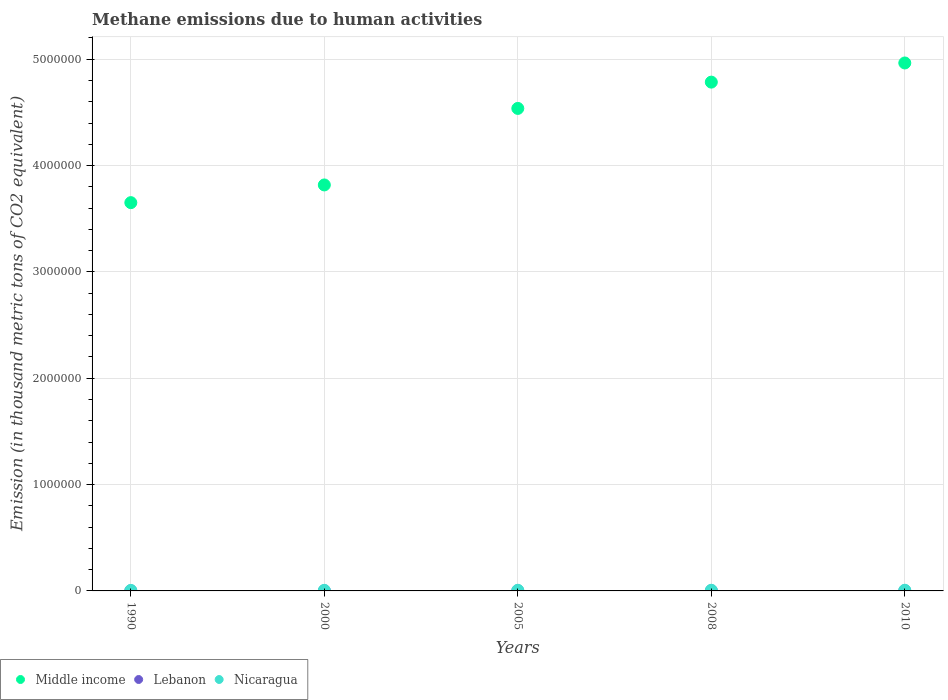How many different coloured dotlines are there?
Provide a short and direct response. 3. Is the number of dotlines equal to the number of legend labels?
Provide a short and direct response. Yes. What is the amount of methane emitted in Nicaragua in 2010?
Your answer should be very brief. 6361.4. Across all years, what is the maximum amount of methane emitted in Middle income?
Provide a succinct answer. 4.96e+06. Across all years, what is the minimum amount of methane emitted in Lebanon?
Make the answer very short. 699. In which year was the amount of methane emitted in Middle income minimum?
Your answer should be compact. 1990. What is the total amount of methane emitted in Middle income in the graph?
Give a very brief answer. 2.18e+07. What is the difference between the amount of methane emitted in Lebanon in 1990 and that in 2000?
Make the answer very short. -207.6. What is the difference between the amount of methane emitted in Middle income in 1990 and the amount of methane emitted in Nicaragua in 2000?
Your answer should be very brief. 3.65e+06. What is the average amount of methane emitted in Lebanon per year?
Your answer should be compact. 969.9. In the year 2005, what is the difference between the amount of methane emitted in Nicaragua and amount of methane emitted in Lebanon?
Ensure brevity in your answer.  5020.2. What is the ratio of the amount of methane emitted in Nicaragua in 2000 to that in 2005?
Offer a very short reply. 0.92. Is the amount of methane emitted in Nicaragua in 2000 less than that in 2005?
Make the answer very short. Yes. What is the difference between the highest and the second highest amount of methane emitted in Middle income?
Your answer should be very brief. 1.80e+05. What is the difference between the highest and the lowest amount of methane emitted in Lebanon?
Give a very brief answer. 428.4. In how many years, is the amount of methane emitted in Middle income greater than the average amount of methane emitted in Middle income taken over all years?
Provide a succinct answer. 3. How many years are there in the graph?
Keep it short and to the point. 5. What is the difference between two consecutive major ticks on the Y-axis?
Ensure brevity in your answer.  1.00e+06. Does the graph contain any zero values?
Your answer should be compact. No. How many legend labels are there?
Keep it short and to the point. 3. How are the legend labels stacked?
Offer a terse response. Horizontal. What is the title of the graph?
Your response must be concise. Methane emissions due to human activities. Does "Mali" appear as one of the legend labels in the graph?
Give a very brief answer. No. What is the label or title of the Y-axis?
Provide a succinct answer. Emission (in thousand metric tons of CO2 equivalent). What is the Emission (in thousand metric tons of CO2 equivalent) of Middle income in 1990?
Give a very brief answer. 3.65e+06. What is the Emission (in thousand metric tons of CO2 equivalent) in Lebanon in 1990?
Provide a succinct answer. 699. What is the Emission (in thousand metric tons of CO2 equivalent) in Nicaragua in 1990?
Ensure brevity in your answer.  4811.3. What is the Emission (in thousand metric tons of CO2 equivalent) in Middle income in 2000?
Your response must be concise. 3.82e+06. What is the Emission (in thousand metric tons of CO2 equivalent) of Lebanon in 2000?
Make the answer very short. 906.6. What is the Emission (in thousand metric tons of CO2 equivalent) of Nicaragua in 2000?
Offer a terse response. 5565.7. What is the Emission (in thousand metric tons of CO2 equivalent) of Middle income in 2005?
Offer a very short reply. 4.54e+06. What is the Emission (in thousand metric tons of CO2 equivalent) in Lebanon in 2005?
Give a very brief answer. 1024.8. What is the Emission (in thousand metric tons of CO2 equivalent) of Nicaragua in 2005?
Offer a very short reply. 6045. What is the Emission (in thousand metric tons of CO2 equivalent) in Middle income in 2008?
Provide a succinct answer. 4.78e+06. What is the Emission (in thousand metric tons of CO2 equivalent) of Lebanon in 2008?
Make the answer very short. 1091.7. What is the Emission (in thousand metric tons of CO2 equivalent) of Nicaragua in 2008?
Ensure brevity in your answer.  6199.5. What is the Emission (in thousand metric tons of CO2 equivalent) of Middle income in 2010?
Keep it short and to the point. 4.96e+06. What is the Emission (in thousand metric tons of CO2 equivalent) in Lebanon in 2010?
Ensure brevity in your answer.  1127.4. What is the Emission (in thousand metric tons of CO2 equivalent) in Nicaragua in 2010?
Provide a short and direct response. 6361.4. Across all years, what is the maximum Emission (in thousand metric tons of CO2 equivalent) of Middle income?
Offer a terse response. 4.96e+06. Across all years, what is the maximum Emission (in thousand metric tons of CO2 equivalent) of Lebanon?
Your answer should be compact. 1127.4. Across all years, what is the maximum Emission (in thousand metric tons of CO2 equivalent) in Nicaragua?
Provide a short and direct response. 6361.4. Across all years, what is the minimum Emission (in thousand metric tons of CO2 equivalent) in Middle income?
Give a very brief answer. 3.65e+06. Across all years, what is the minimum Emission (in thousand metric tons of CO2 equivalent) in Lebanon?
Ensure brevity in your answer.  699. Across all years, what is the minimum Emission (in thousand metric tons of CO2 equivalent) in Nicaragua?
Your answer should be very brief. 4811.3. What is the total Emission (in thousand metric tons of CO2 equivalent) in Middle income in the graph?
Your response must be concise. 2.18e+07. What is the total Emission (in thousand metric tons of CO2 equivalent) in Lebanon in the graph?
Provide a succinct answer. 4849.5. What is the total Emission (in thousand metric tons of CO2 equivalent) of Nicaragua in the graph?
Make the answer very short. 2.90e+04. What is the difference between the Emission (in thousand metric tons of CO2 equivalent) in Middle income in 1990 and that in 2000?
Make the answer very short. -1.67e+05. What is the difference between the Emission (in thousand metric tons of CO2 equivalent) of Lebanon in 1990 and that in 2000?
Keep it short and to the point. -207.6. What is the difference between the Emission (in thousand metric tons of CO2 equivalent) of Nicaragua in 1990 and that in 2000?
Give a very brief answer. -754.4. What is the difference between the Emission (in thousand metric tons of CO2 equivalent) in Middle income in 1990 and that in 2005?
Keep it short and to the point. -8.86e+05. What is the difference between the Emission (in thousand metric tons of CO2 equivalent) in Lebanon in 1990 and that in 2005?
Offer a very short reply. -325.8. What is the difference between the Emission (in thousand metric tons of CO2 equivalent) in Nicaragua in 1990 and that in 2005?
Make the answer very short. -1233.7. What is the difference between the Emission (in thousand metric tons of CO2 equivalent) of Middle income in 1990 and that in 2008?
Make the answer very short. -1.13e+06. What is the difference between the Emission (in thousand metric tons of CO2 equivalent) in Lebanon in 1990 and that in 2008?
Offer a terse response. -392.7. What is the difference between the Emission (in thousand metric tons of CO2 equivalent) of Nicaragua in 1990 and that in 2008?
Provide a short and direct response. -1388.2. What is the difference between the Emission (in thousand metric tons of CO2 equivalent) in Middle income in 1990 and that in 2010?
Your response must be concise. -1.31e+06. What is the difference between the Emission (in thousand metric tons of CO2 equivalent) in Lebanon in 1990 and that in 2010?
Provide a short and direct response. -428.4. What is the difference between the Emission (in thousand metric tons of CO2 equivalent) of Nicaragua in 1990 and that in 2010?
Provide a short and direct response. -1550.1. What is the difference between the Emission (in thousand metric tons of CO2 equivalent) of Middle income in 2000 and that in 2005?
Your answer should be compact. -7.20e+05. What is the difference between the Emission (in thousand metric tons of CO2 equivalent) in Lebanon in 2000 and that in 2005?
Your answer should be compact. -118.2. What is the difference between the Emission (in thousand metric tons of CO2 equivalent) in Nicaragua in 2000 and that in 2005?
Offer a terse response. -479.3. What is the difference between the Emission (in thousand metric tons of CO2 equivalent) of Middle income in 2000 and that in 2008?
Provide a succinct answer. -9.67e+05. What is the difference between the Emission (in thousand metric tons of CO2 equivalent) of Lebanon in 2000 and that in 2008?
Provide a succinct answer. -185.1. What is the difference between the Emission (in thousand metric tons of CO2 equivalent) in Nicaragua in 2000 and that in 2008?
Offer a very short reply. -633.8. What is the difference between the Emission (in thousand metric tons of CO2 equivalent) of Middle income in 2000 and that in 2010?
Your answer should be very brief. -1.15e+06. What is the difference between the Emission (in thousand metric tons of CO2 equivalent) of Lebanon in 2000 and that in 2010?
Your answer should be very brief. -220.8. What is the difference between the Emission (in thousand metric tons of CO2 equivalent) of Nicaragua in 2000 and that in 2010?
Offer a terse response. -795.7. What is the difference between the Emission (in thousand metric tons of CO2 equivalent) in Middle income in 2005 and that in 2008?
Your answer should be very brief. -2.47e+05. What is the difference between the Emission (in thousand metric tons of CO2 equivalent) of Lebanon in 2005 and that in 2008?
Provide a short and direct response. -66.9. What is the difference between the Emission (in thousand metric tons of CO2 equivalent) in Nicaragua in 2005 and that in 2008?
Ensure brevity in your answer.  -154.5. What is the difference between the Emission (in thousand metric tons of CO2 equivalent) in Middle income in 2005 and that in 2010?
Provide a short and direct response. -4.27e+05. What is the difference between the Emission (in thousand metric tons of CO2 equivalent) in Lebanon in 2005 and that in 2010?
Make the answer very short. -102.6. What is the difference between the Emission (in thousand metric tons of CO2 equivalent) of Nicaragua in 2005 and that in 2010?
Give a very brief answer. -316.4. What is the difference between the Emission (in thousand metric tons of CO2 equivalent) of Middle income in 2008 and that in 2010?
Make the answer very short. -1.80e+05. What is the difference between the Emission (in thousand metric tons of CO2 equivalent) of Lebanon in 2008 and that in 2010?
Offer a very short reply. -35.7. What is the difference between the Emission (in thousand metric tons of CO2 equivalent) of Nicaragua in 2008 and that in 2010?
Offer a very short reply. -161.9. What is the difference between the Emission (in thousand metric tons of CO2 equivalent) of Middle income in 1990 and the Emission (in thousand metric tons of CO2 equivalent) of Lebanon in 2000?
Offer a very short reply. 3.65e+06. What is the difference between the Emission (in thousand metric tons of CO2 equivalent) in Middle income in 1990 and the Emission (in thousand metric tons of CO2 equivalent) in Nicaragua in 2000?
Offer a very short reply. 3.65e+06. What is the difference between the Emission (in thousand metric tons of CO2 equivalent) in Lebanon in 1990 and the Emission (in thousand metric tons of CO2 equivalent) in Nicaragua in 2000?
Your answer should be compact. -4866.7. What is the difference between the Emission (in thousand metric tons of CO2 equivalent) of Middle income in 1990 and the Emission (in thousand metric tons of CO2 equivalent) of Lebanon in 2005?
Keep it short and to the point. 3.65e+06. What is the difference between the Emission (in thousand metric tons of CO2 equivalent) in Middle income in 1990 and the Emission (in thousand metric tons of CO2 equivalent) in Nicaragua in 2005?
Your response must be concise. 3.65e+06. What is the difference between the Emission (in thousand metric tons of CO2 equivalent) in Lebanon in 1990 and the Emission (in thousand metric tons of CO2 equivalent) in Nicaragua in 2005?
Keep it short and to the point. -5346. What is the difference between the Emission (in thousand metric tons of CO2 equivalent) of Middle income in 1990 and the Emission (in thousand metric tons of CO2 equivalent) of Lebanon in 2008?
Give a very brief answer. 3.65e+06. What is the difference between the Emission (in thousand metric tons of CO2 equivalent) in Middle income in 1990 and the Emission (in thousand metric tons of CO2 equivalent) in Nicaragua in 2008?
Ensure brevity in your answer.  3.65e+06. What is the difference between the Emission (in thousand metric tons of CO2 equivalent) in Lebanon in 1990 and the Emission (in thousand metric tons of CO2 equivalent) in Nicaragua in 2008?
Your answer should be very brief. -5500.5. What is the difference between the Emission (in thousand metric tons of CO2 equivalent) of Middle income in 1990 and the Emission (in thousand metric tons of CO2 equivalent) of Lebanon in 2010?
Provide a succinct answer. 3.65e+06. What is the difference between the Emission (in thousand metric tons of CO2 equivalent) in Middle income in 1990 and the Emission (in thousand metric tons of CO2 equivalent) in Nicaragua in 2010?
Provide a succinct answer. 3.64e+06. What is the difference between the Emission (in thousand metric tons of CO2 equivalent) in Lebanon in 1990 and the Emission (in thousand metric tons of CO2 equivalent) in Nicaragua in 2010?
Make the answer very short. -5662.4. What is the difference between the Emission (in thousand metric tons of CO2 equivalent) of Middle income in 2000 and the Emission (in thousand metric tons of CO2 equivalent) of Lebanon in 2005?
Offer a very short reply. 3.82e+06. What is the difference between the Emission (in thousand metric tons of CO2 equivalent) in Middle income in 2000 and the Emission (in thousand metric tons of CO2 equivalent) in Nicaragua in 2005?
Give a very brief answer. 3.81e+06. What is the difference between the Emission (in thousand metric tons of CO2 equivalent) in Lebanon in 2000 and the Emission (in thousand metric tons of CO2 equivalent) in Nicaragua in 2005?
Provide a short and direct response. -5138.4. What is the difference between the Emission (in thousand metric tons of CO2 equivalent) of Middle income in 2000 and the Emission (in thousand metric tons of CO2 equivalent) of Lebanon in 2008?
Keep it short and to the point. 3.82e+06. What is the difference between the Emission (in thousand metric tons of CO2 equivalent) in Middle income in 2000 and the Emission (in thousand metric tons of CO2 equivalent) in Nicaragua in 2008?
Keep it short and to the point. 3.81e+06. What is the difference between the Emission (in thousand metric tons of CO2 equivalent) of Lebanon in 2000 and the Emission (in thousand metric tons of CO2 equivalent) of Nicaragua in 2008?
Your response must be concise. -5292.9. What is the difference between the Emission (in thousand metric tons of CO2 equivalent) of Middle income in 2000 and the Emission (in thousand metric tons of CO2 equivalent) of Lebanon in 2010?
Provide a short and direct response. 3.82e+06. What is the difference between the Emission (in thousand metric tons of CO2 equivalent) of Middle income in 2000 and the Emission (in thousand metric tons of CO2 equivalent) of Nicaragua in 2010?
Offer a very short reply. 3.81e+06. What is the difference between the Emission (in thousand metric tons of CO2 equivalent) of Lebanon in 2000 and the Emission (in thousand metric tons of CO2 equivalent) of Nicaragua in 2010?
Ensure brevity in your answer.  -5454.8. What is the difference between the Emission (in thousand metric tons of CO2 equivalent) of Middle income in 2005 and the Emission (in thousand metric tons of CO2 equivalent) of Lebanon in 2008?
Provide a short and direct response. 4.54e+06. What is the difference between the Emission (in thousand metric tons of CO2 equivalent) of Middle income in 2005 and the Emission (in thousand metric tons of CO2 equivalent) of Nicaragua in 2008?
Make the answer very short. 4.53e+06. What is the difference between the Emission (in thousand metric tons of CO2 equivalent) of Lebanon in 2005 and the Emission (in thousand metric tons of CO2 equivalent) of Nicaragua in 2008?
Make the answer very short. -5174.7. What is the difference between the Emission (in thousand metric tons of CO2 equivalent) of Middle income in 2005 and the Emission (in thousand metric tons of CO2 equivalent) of Lebanon in 2010?
Your answer should be very brief. 4.54e+06. What is the difference between the Emission (in thousand metric tons of CO2 equivalent) in Middle income in 2005 and the Emission (in thousand metric tons of CO2 equivalent) in Nicaragua in 2010?
Your response must be concise. 4.53e+06. What is the difference between the Emission (in thousand metric tons of CO2 equivalent) of Lebanon in 2005 and the Emission (in thousand metric tons of CO2 equivalent) of Nicaragua in 2010?
Provide a succinct answer. -5336.6. What is the difference between the Emission (in thousand metric tons of CO2 equivalent) in Middle income in 2008 and the Emission (in thousand metric tons of CO2 equivalent) in Lebanon in 2010?
Make the answer very short. 4.78e+06. What is the difference between the Emission (in thousand metric tons of CO2 equivalent) in Middle income in 2008 and the Emission (in thousand metric tons of CO2 equivalent) in Nicaragua in 2010?
Give a very brief answer. 4.78e+06. What is the difference between the Emission (in thousand metric tons of CO2 equivalent) of Lebanon in 2008 and the Emission (in thousand metric tons of CO2 equivalent) of Nicaragua in 2010?
Your response must be concise. -5269.7. What is the average Emission (in thousand metric tons of CO2 equivalent) in Middle income per year?
Offer a terse response. 4.35e+06. What is the average Emission (in thousand metric tons of CO2 equivalent) of Lebanon per year?
Provide a short and direct response. 969.9. What is the average Emission (in thousand metric tons of CO2 equivalent) of Nicaragua per year?
Offer a very short reply. 5796.58. In the year 1990, what is the difference between the Emission (in thousand metric tons of CO2 equivalent) in Middle income and Emission (in thousand metric tons of CO2 equivalent) in Lebanon?
Provide a short and direct response. 3.65e+06. In the year 1990, what is the difference between the Emission (in thousand metric tons of CO2 equivalent) of Middle income and Emission (in thousand metric tons of CO2 equivalent) of Nicaragua?
Your response must be concise. 3.65e+06. In the year 1990, what is the difference between the Emission (in thousand metric tons of CO2 equivalent) in Lebanon and Emission (in thousand metric tons of CO2 equivalent) in Nicaragua?
Your answer should be compact. -4112.3. In the year 2000, what is the difference between the Emission (in thousand metric tons of CO2 equivalent) of Middle income and Emission (in thousand metric tons of CO2 equivalent) of Lebanon?
Provide a short and direct response. 3.82e+06. In the year 2000, what is the difference between the Emission (in thousand metric tons of CO2 equivalent) of Middle income and Emission (in thousand metric tons of CO2 equivalent) of Nicaragua?
Your answer should be very brief. 3.81e+06. In the year 2000, what is the difference between the Emission (in thousand metric tons of CO2 equivalent) of Lebanon and Emission (in thousand metric tons of CO2 equivalent) of Nicaragua?
Give a very brief answer. -4659.1. In the year 2005, what is the difference between the Emission (in thousand metric tons of CO2 equivalent) in Middle income and Emission (in thousand metric tons of CO2 equivalent) in Lebanon?
Ensure brevity in your answer.  4.54e+06. In the year 2005, what is the difference between the Emission (in thousand metric tons of CO2 equivalent) of Middle income and Emission (in thousand metric tons of CO2 equivalent) of Nicaragua?
Make the answer very short. 4.53e+06. In the year 2005, what is the difference between the Emission (in thousand metric tons of CO2 equivalent) of Lebanon and Emission (in thousand metric tons of CO2 equivalent) of Nicaragua?
Give a very brief answer. -5020.2. In the year 2008, what is the difference between the Emission (in thousand metric tons of CO2 equivalent) of Middle income and Emission (in thousand metric tons of CO2 equivalent) of Lebanon?
Offer a terse response. 4.78e+06. In the year 2008, what is the difference between the Emission (in thousand metric tons of CO2 equivalent) of Middle income and Emission (in thousand metric tons of CO2 equivalent) of Nicaragua?
Make the answer very short. 4.78e+06. In the year 2008, what is the difference between the Emission (in thousand metric tons of CO2 equivalent) of Lebanon and Emission (in thousand metric tons of CO2 equivalent) of Nicaragua?
Give a very brief answer. -5107.8. In the year 2010, what is the difference between the Emission (in thousand metric tons of CO2 equivalent) in Middle income and Emission (in thousand metric tons of CO2 equivalent) in Lebanon?
Ensure brevity in your answer.  4.96e+06. In the year 2010, what is the difference between the Emission (in thousand metric tons of CO2 equivalent) in Middle income and Emission (in thousand metric tons of CO2 equivalent) in Nicaragua?
Provide a short and direct response. 4.96e+06. In the year 2010, what is the difference between the Emission (in thousand metric tons of CO2 equivalent) of Lebanon and Emission (in thousand metric tons of CO2 equivalent) of Nicaragua?
Offer a terse response. -5234. What is the ratio of the Emission (in thousand metric tons of CO2 equivalent) in Middle income in 1990 to that in 2000?
Make the answer very short. 0.96. What is the ratio of the Emission (in thousand metric tons of CO2 equivalent) of Lebanon in 1990 to that in 2000?
Provide a short and direct response. 0.77. What is the ratio of the Emission (in thousand metric tons of CO2 equivalent) of Nicaragua in 1990 to that in 2000?
Keep it short and to the point. 0.86. What is the ratio of the Emission (in thousand metric tons of CO2 equivalent) of Middle income in 1990 to that in 2005?
Your answer should be compact. 0.8. What is the ratio of the Emission (in thousand metric tons of CO2 equivalent) of Lebanon in 1990 to that in 2005?
Ensure brevity in your answer.  0.68. What is the ratio of the Emission (in thousand metric tons of CO2 equivalent) of Nicaragua in 1990 to that in 2005?
Provide a short and direct response. 0.8. What is the ratio of the Emission (in thousand metric tons of CO2 equivalent) of Middle income in 1990 to that in 2008?
Ensure brevity in your answer.  0.76. What is the ratio of the Emission (in thousand metric tons of CO2 equivalent) of Lebanon in 1990 to that in 2008?
Offer a terse response. 0.64. What is the ratio of the Emission (in thousand metric tons of CO2 equivalent) in Nicaragua in 1990 to that in 2008?
Keep it short and to the point. 0.78. What is the ratio of the Emission (in thousand metric tons of CO2 equivalent) in Middle income in 1990 to that in 2010?
Keep it short and to the point. 0.74. What is the ratio of the Emission (in thousand metric tons of CO2 equivalent) of Lebanon in 1990 to that in 2010?
Keep it short and to the point. 0.62. What is the ratio of the Emission (in thousand metric tons of CO2 equivalent) in Nicaragua in 1990 to that in 2010?
Offer a very short reply. 0.76. What is the ratio of the Emission (in thousand metric tons of CO2 equivalent) of Middle income in 2000 to that in 2005?
Your answer should be compact. 0.84. What is the ratio of the Emission (in thousand metric tons of CO2 equivalent) of Lebanon in 2000 to that in 2005?
Provide a short and direct response. 0.88. What is the ratio of the Emission (in thousand metric tons of CO2 equivalent) of Nicaragua in 2000 to that in 2005?
Your answer should be compact. 0.92. What is the ratio of the Emission (in thousand metric tons of CO2 equivalent) of Middle income in 2000 to that in 2008?
Offer a terse response. 0.8. What is the ratio of the Emission (in thousand metric tons of CO2 equivalent) in Lebanon in 2000 to that in 2008?
Ensure brevity in your answer.  0.83. What is the ratio of the Emission (in thousand metric tons of CO2 equivalent) of Nicaragua in 2000 to that in 2008?
Offer a very short reply. 0.9. What is the ratio of the Emission (in thousand metric tons of CO2 equivalent) of Middle income in 2000 to that in 2010?
Give a very brief answer. 0.77. What is the ratio of the Emission (in thousand metric tons of CO2 equivalent) of Lebanon in 2000 to that in 2010?
Make the answer very short. 0.8. What is the ratio of the Emission (in thousand metric tons of CO2 equivalent) of Nicaragua in 2000 to that in 2010?
Keep it short and to the point. 0.87. What is the ratio of the Emission (in thousand metric tons of CO2 equivalent) of Middle income in 2005 to that in 2008?
Ensure brevity in your answer.  0.95. What is the ratio of the Emission (in thousand metric tons of CO2 equivalent) of Lebanon in 2005 to that in 2008?
Ensure brevity in your answer.  0.94. What is the ratio of the Emission (in thousand metric tons of CO2 equivalent) in Nicaragua in 2005 to that in 2008?
Ensure brevity in your answer.  0.98. What is the ratio of the Emission (in thousand metric tons of CO2 equivalent) in Middle income in 2005 to that in 2010?
Your response must be concise. 0.91. What is the ratio of the Emission (in thousand metric tons of CO2 equivalent) of Lebanon in 2005 to that in 2010?
Offer a terse response. 0.91. What is the ratio of the Emission (in thousand metric tons of CO2 equivalent) in Nicaragua in 2005 to that in 2010?
Your response must be concise. 0.95. What is the ratio of the Emission (in thousand metric tons of CO2 equivalent) of Middle income in 2008 to that in 2010?
Offer a terse response. 0.96. What is the ratio of the Emission (in thousand metric tons of CO2 equivalent) in Lebanon in 2008 to that in 2010?
Offer a very short reply. 0.97. What is the ratio of the Emission (in thousand metric tons of CO2 equivalent) of Nicaragua in 2008 to that in 2010?
Your response must be concise. 0.97. What is the difference between the highest and the second highest Emission (in thousand metric tons of CO2 equivalent) of Middle income?
Your answer should be compact. 1.80e+05. What is the difference between the highest and the second highest Emission (in thousand metric tons of CO2 equivalent) in Lebanon?
Your answer should be very brief. 35.7. What is the difference between the highest and the second highest Emission (in thousand metric tons of CO2 equivalent) in Nicaragua?
Keep it short and to the point. 161.9. What is the difference between the highest and the lowest Emission (in thousand metric tons of CO2 equivalent) of Middle income?
Give a very brief answer. 1.31e+06. What is the difference between the highest and the lowest Emission (in thousand metric tons of CO2 equivalent) in Lebanon?
Your answer should be compact. 428.4. What is the difference between the highest and the lowest Emission (in thousand metric tons of CO2 equivalent) in Nicaragua?
Make the answer very short. 1550.1. 